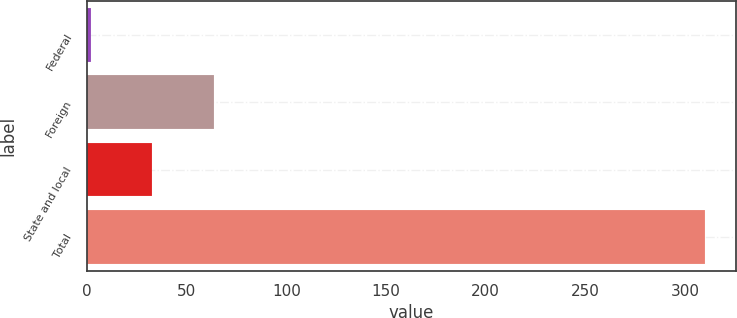<chart> <loc_0><loc_0><loc_500><loc_500><bar_chart><fcel>Federal<fcel>Foreign<fcel>State and local<fcel>Total<nl><fcel>2<fcel>63.6<fcel>32.8<fcel>310<nl></chart> 